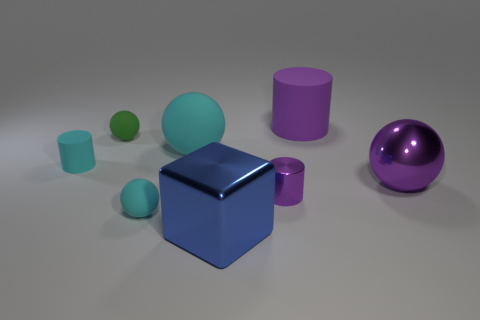What could be the context or use of these objects? These objects may be used for various purposes, such as educational tools to teach about geometry and colors, elements in a digital artwork, or as part of a computer graphics demonstrative scene to showcase rendering techniques like lighting, shadow, and reflections. 